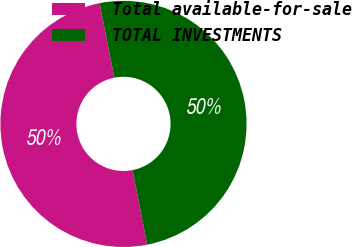Convert chart. <chart><loc_0><loc_0><loc_500><loc_500><pie_chart><fcel>Total available-for-sale<fcel>TOTAL INVESTMENTS<nl><fcel>49.98%<fcel>50.02%<nl></chart> 